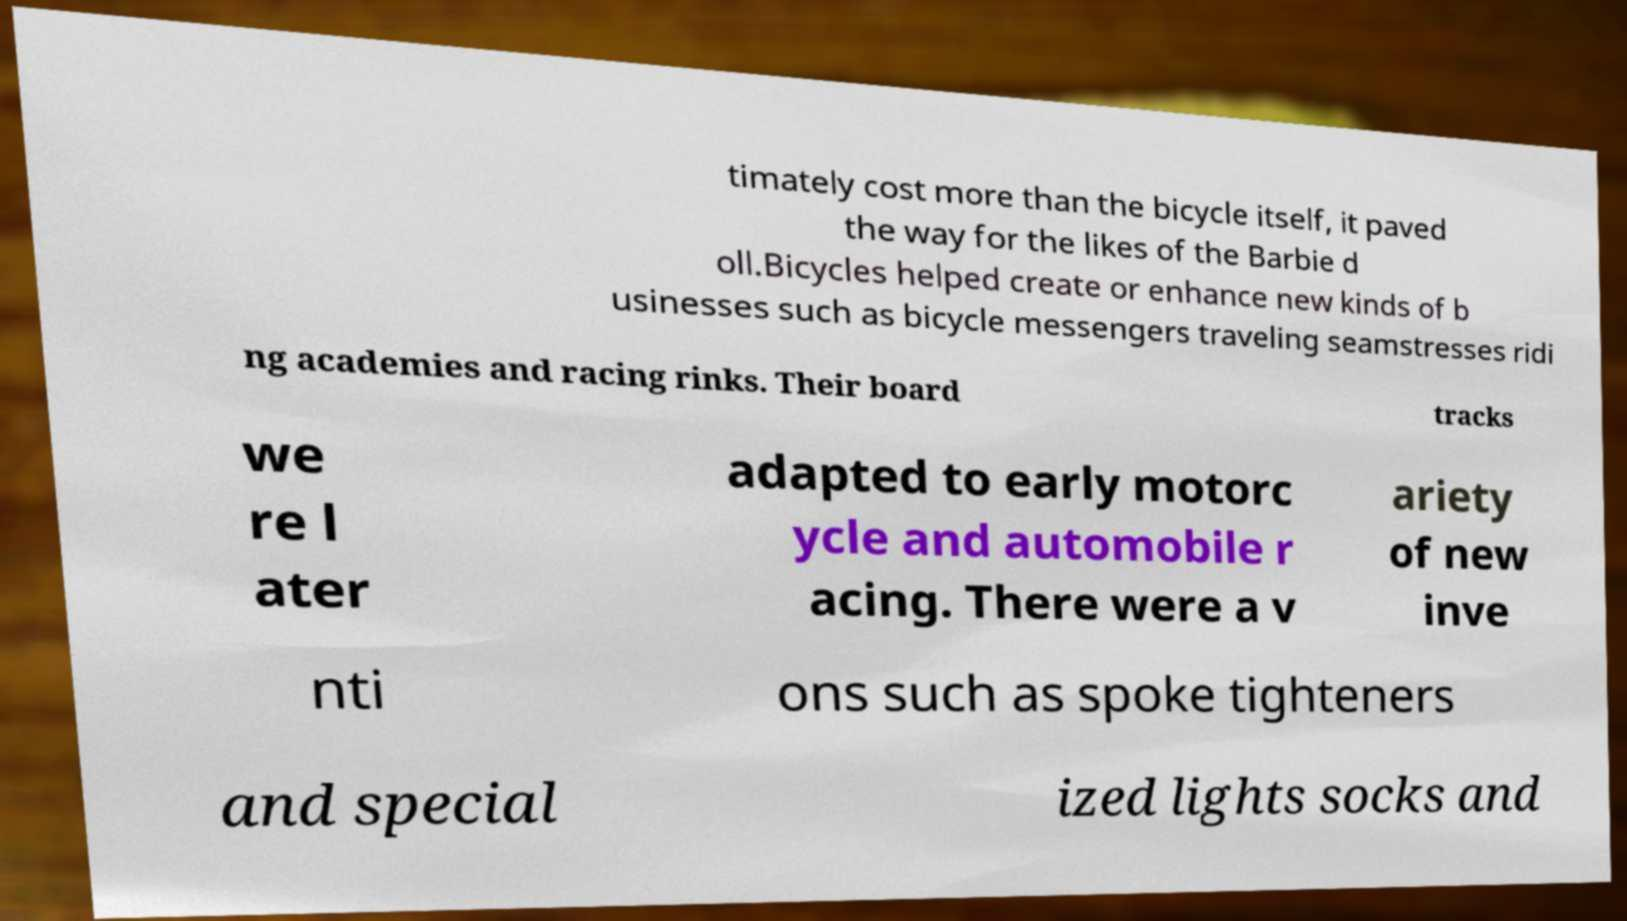For documentation purposes, I need the text within this image transcribed. Could you provide that? timately cost more than the bicycle itself, it paved the way for the likes of the Barbie d oll.Bicycles helped create or enhance new kinds of b usinesses such as bicycle messengers traveling seamstresses ridi ng academies and racing rinks. Their board tracks we re l ater adapted to early motorc ycle and automobile r acing. There were a v ariety of new inve nti ons such as spoke tighteners and special ized lights socks and 